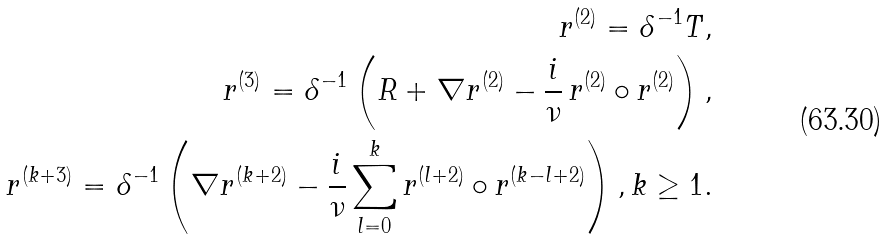Convert formula to latex. <formula><loc_0><loc_0><loc_500><loc_500>r ^ { ( 2 ) } = \delta ^ { - 1 } T , \\ r ^ { ( 3 ) } = \delta ^ { - 1 } \left ( R + \nabla r ^ { ( 2 ) } - \frac { i } { \nu } \, r ^ { ( 2 ) } \circ r ^ { ( 2 ) } \right ) , \\ r ^ { ( k + 3 ) } = \delta ^ { - 1 } \left ( \nabla r ^ { ( k + 2 ) } - \frac { i } { \nu } \sum _ { l = 0 } ^ { k } r ^ { ( l + 2 ) } \circ r ^ { ( k - l + 2 ) } \right ) , k \geq 1 .</formula> 